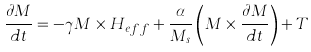Convert formula to latex. <formula><loc_0><loc_0><loc_500><loc_500>\frac { \partial { M } } { d t } = - \gamma { M } \times { H } _ { e f f } + \frac { \alpha } { M _ { s } } \left ( { M } \times \frac { \partial M } { d t } \right ) + { T }</formula> 